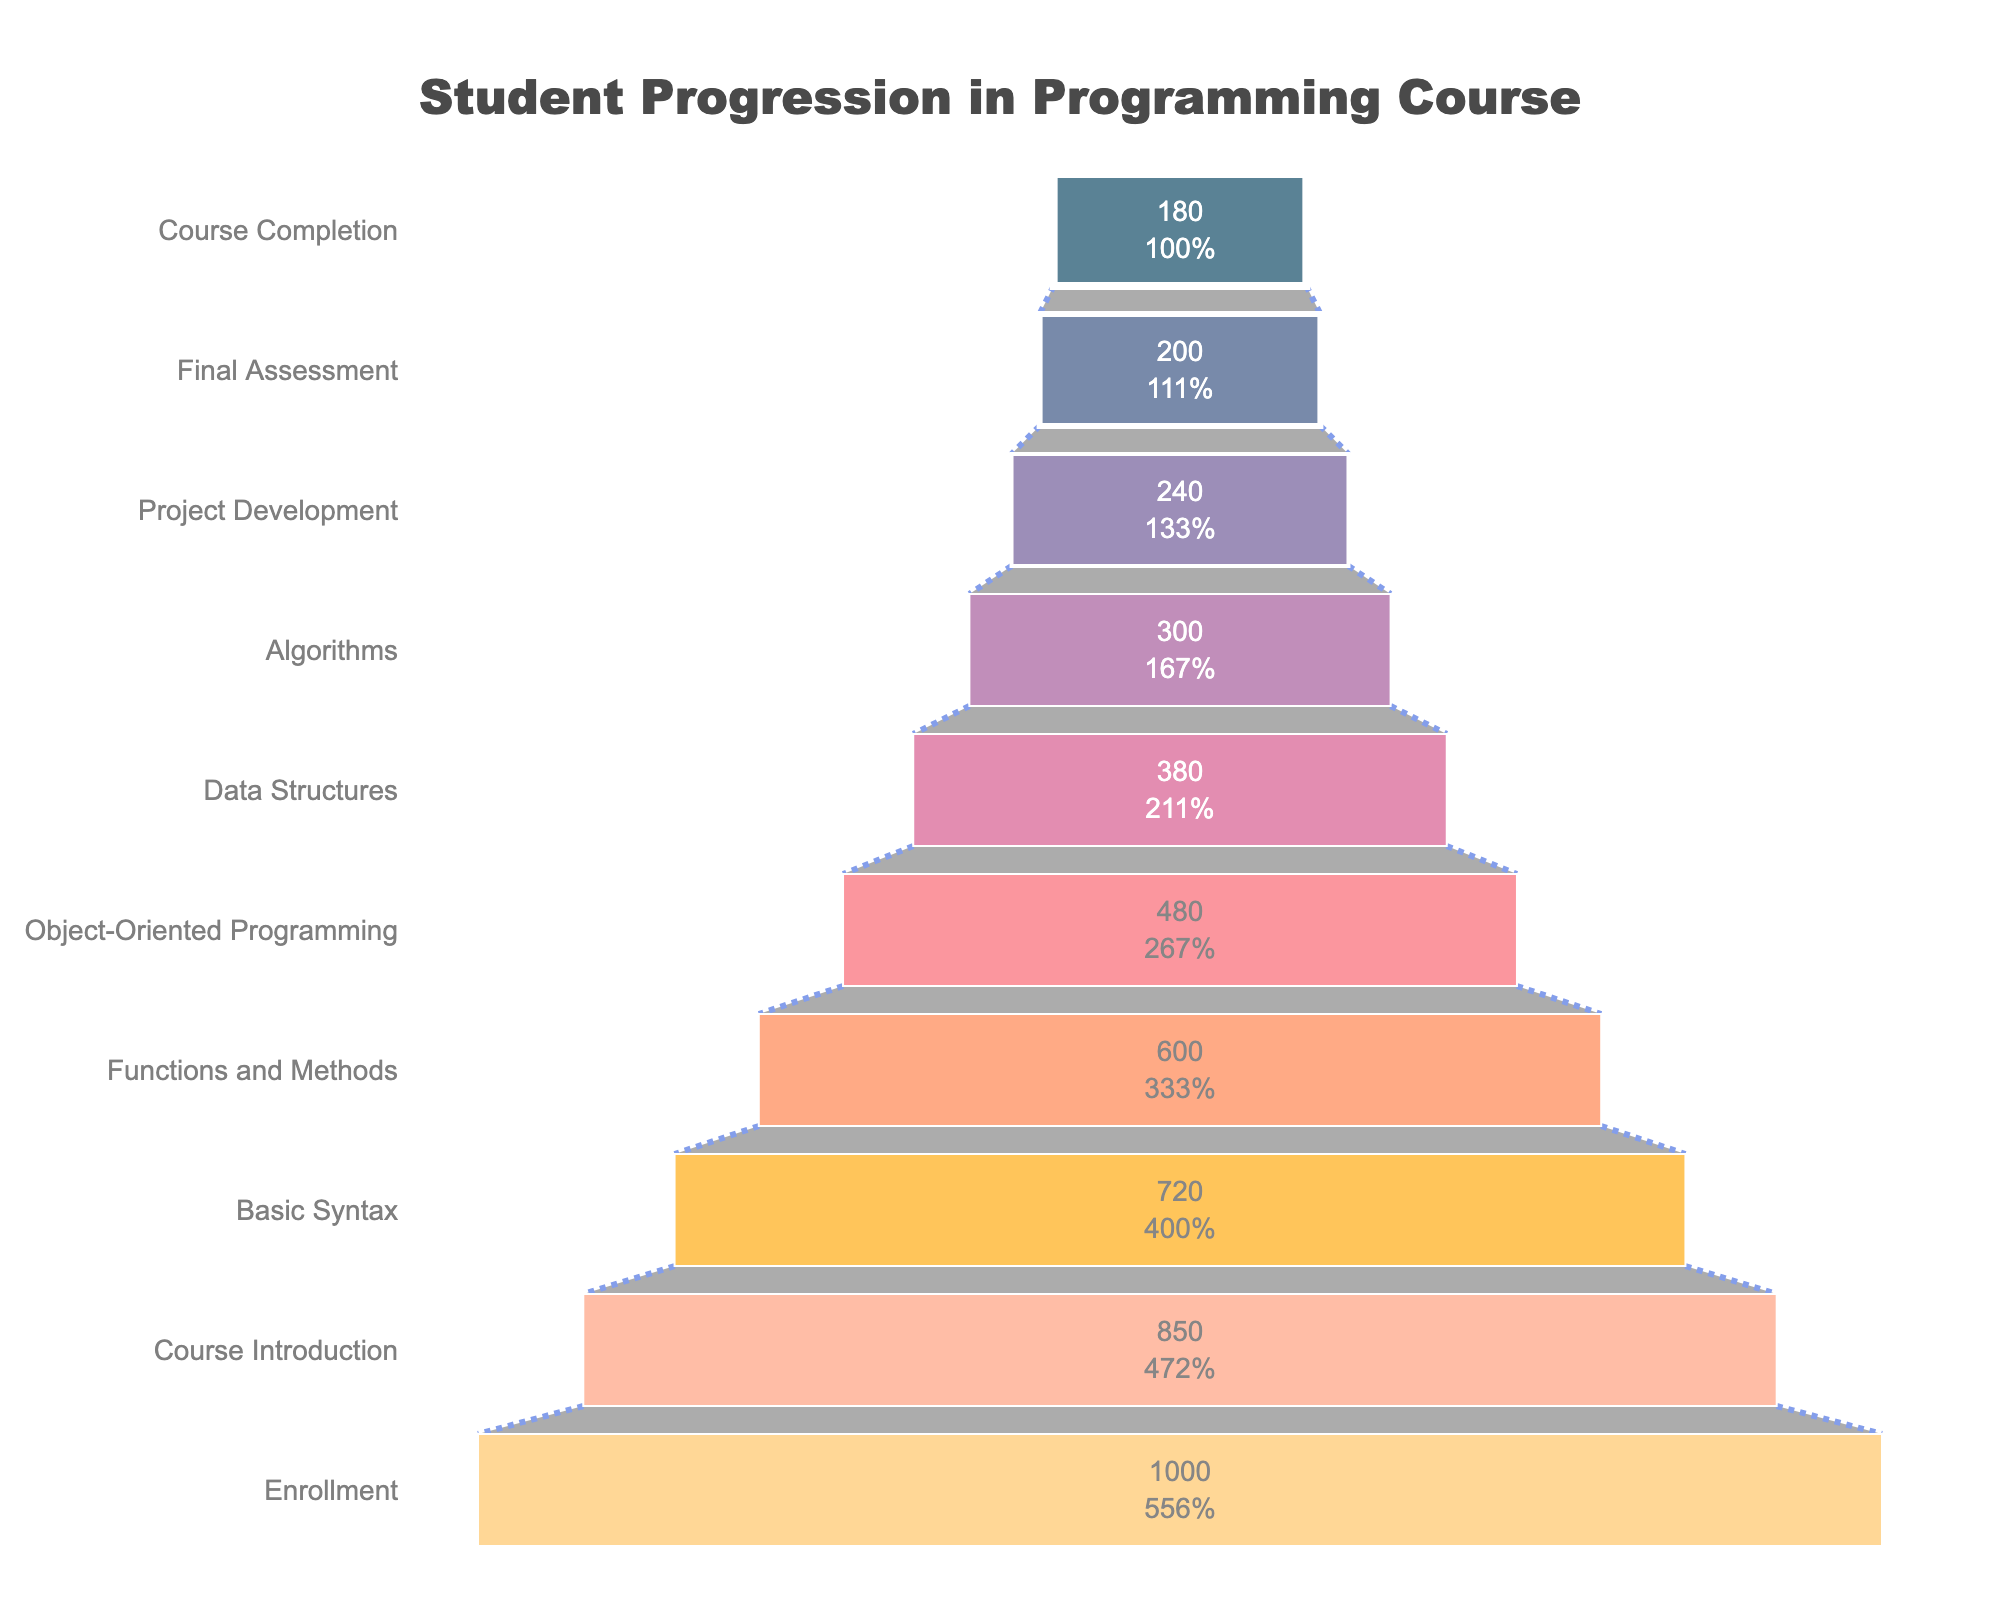How many stages are shown in the chart? Count the stages listed on the y-axis in the figure. There are 10 stages displayed.
Answer: 10 How many students completed the course? Look at the "Course Completion" stage on the y-axis and read the corresponding student count on the x-axis. The number of students is 180.
Answer: 180 What is the percentage drop from "Enrollment" to "Course Completion"? First, find the starting number of students at "Enrollment" (1000) and the ending number at "Course Completion" (180). Calculate the drop by using the formula: ((1000 - 180) / 1000) * 100.
Answer: 82% How many more students completed "Basic Syntax" than "Data Structures"? Find the student counts for "Basic Syntax" (720) and "Data Structures" (380). Subtract the latter from the former: 720 - 380.
Answer: 340 Which stage has the highest number of students, and what is that number? Look at the student counts along the x-axis for each stage and identify the highest value, which is the "Enrollment" stage with 1000 students.
Answer: Enrollment, 1000 What is the smallest drop in student count between any two consecutive stages in the chart? Calculate the differences between student counts for each pair of consecutive stages to find the smallest drop. The smallest drop is between "Project Development" (240) and "Final Assessment" (200), which is 40 students.
Answer: 40 What percentage of students reached "Project Development"? The number of students at "Project Development" is 240 out of the initial 1000. Calculate the percentage: (240 / 1000) * 100.
Answer: 24% Which stage experienced the highest drop in student numbers compared to its previous stage? Calculate student number drops between all consecutive stages and find the highest drop. The highest drop is from "Course Introduction" (850) to "Basic Syntax" (720), which is a drop of 130 students.
Answer: Course Introduction to Basic Syntax How many students advanced from "Functions and Methods" to "Object-Oriented Programming"? Find the student numbers for "Functions and Methods" (600) and "Object-Oriented Programming" (480). The number that advanced is 480.
Answer: 480 What is the percentage completion rate of students taking the final assessment? Look at the "Final Assessment" stage and the "Course Completion" stage. The percentage is (180 / 200) * 100.
Answer: 90% 